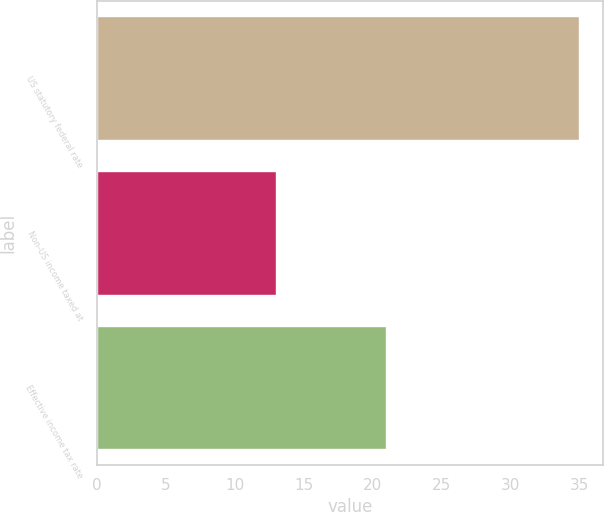<chart> <loc_0><loc_0><loc_500><loc_500><bar_chart><fcel>US statutory federal rate<fcel>Non-US income taxed at<fcel>Effective income tax rate<nl><fcel>35<fcel>13<fcel>21<nl></chart> 